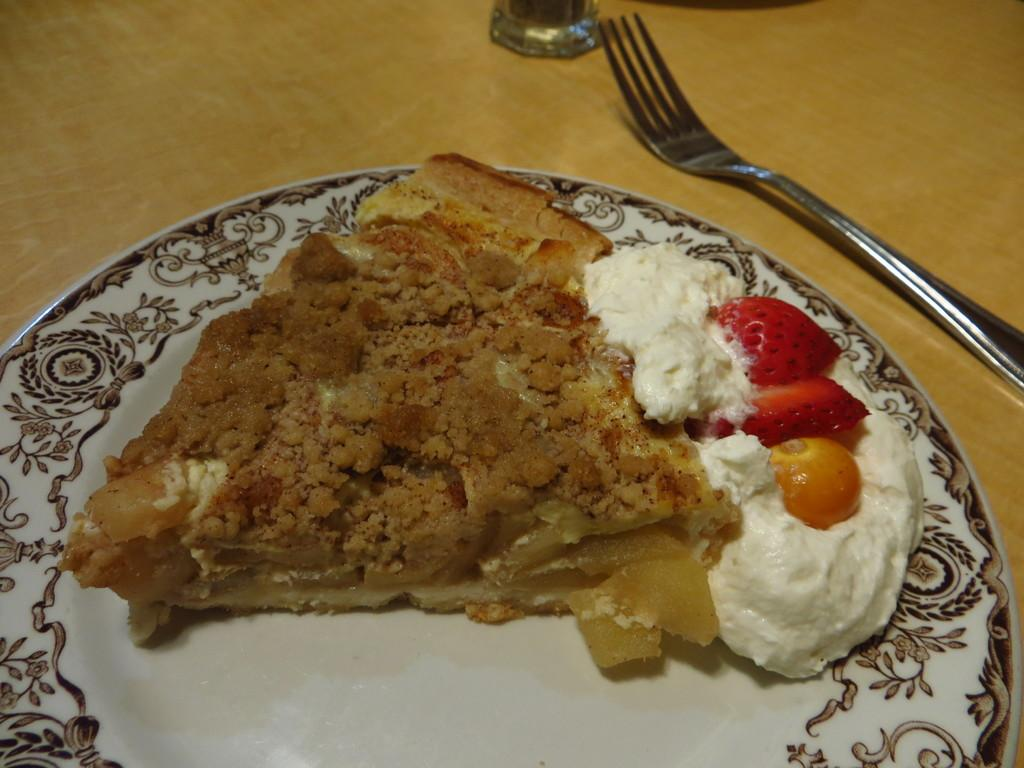What type of food items can be seen in the image? There are food items in the image, including ice cream and strawberries. What color is the plate containing the food items? The plate is white in color. What utensil is present in the image? There is a fork in the image. What type of surface is visible in the image? The wooden surface is present in the image. What is the weight of the sail in the image? There is no sail present in the image; it is a plate of food items with a fork on a wooden surface. 